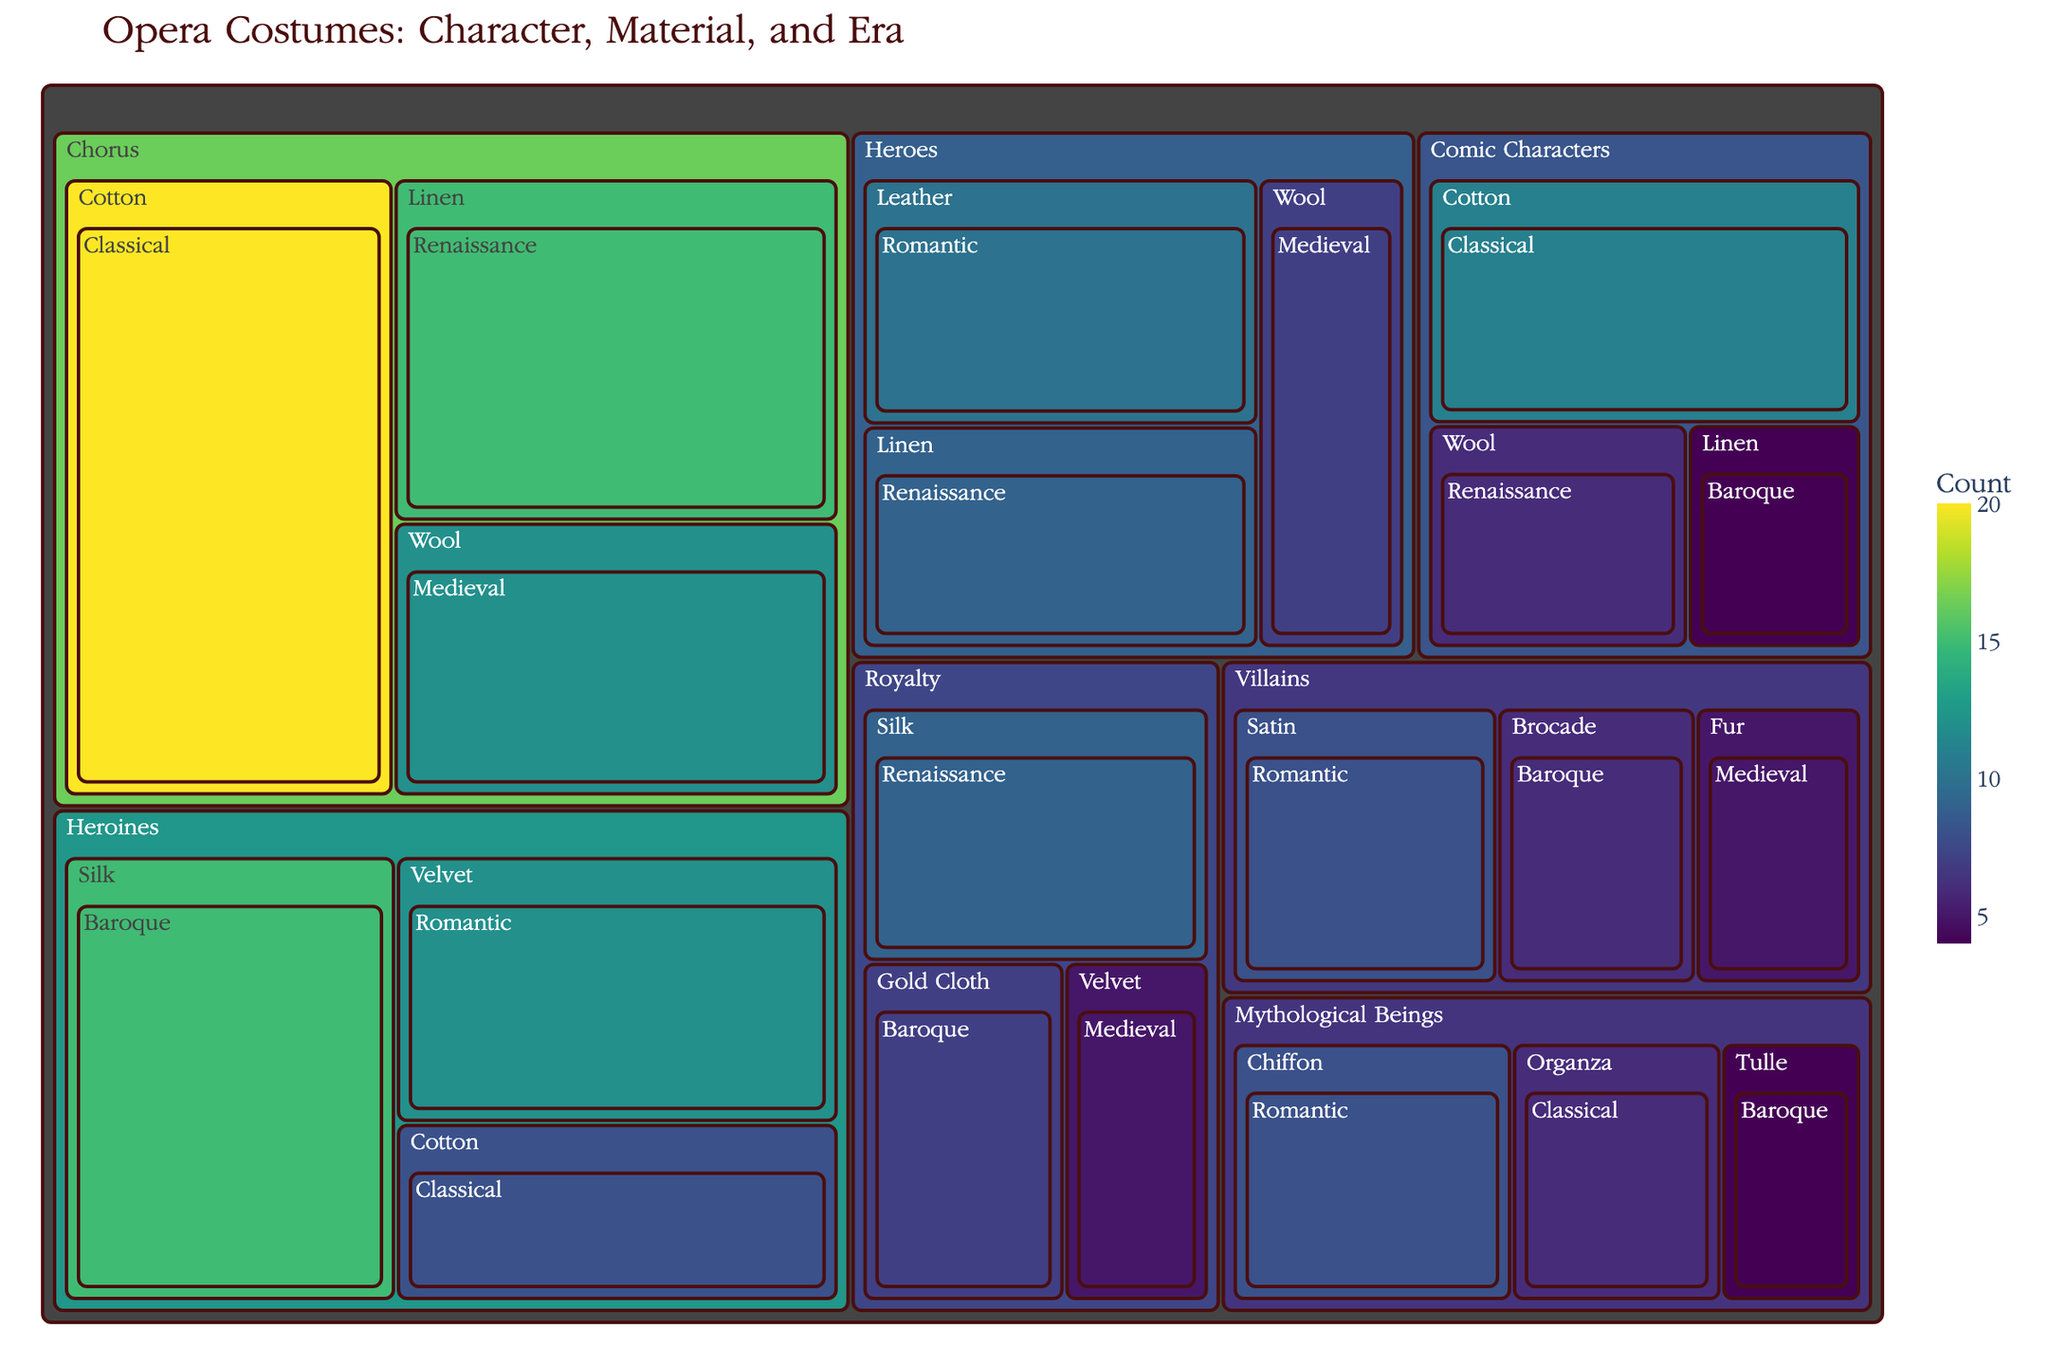What is the title of the treemap? The title of the treemap is typically displayed prominently at the top. In this case, the title is provided by us: 'Opera Costumes: Character, Material, and Era'
Answer: Opera Costumes: Character, Material, and Era What color scale is used in the treemap? The color scale is defined in the code as 'Viridis'. This scale is typically a gradient of colors transitioning from dark to light to represent the count values.
Answer: Viridis Which character type has the highest count of costumes? Look for the largest area in the treemap. The largest area corresponds to the 'Chorus', with a sum of counts from different materials and eras adding up to be the highest.
Answer: Chorus What is the total number of 'Royalty' costumes? Sum the counts of all 'Royalty' costumes across different materials and eras: 7 (Gold Cloth, Baroque) + 9 (Silk, Renaissance) + 5 (Velvet, Medieval) = 21.
Answer: 21 Which era has the most 'Heroines' costumes made of silk? Locate data points within 'Heroines' and distinguish by material and era. The count for silk in the Baroque era is 15, which is the highest for Heroines with silk.
Answer: Baroque Compare the number of 'Heroes' costumes made of wool with the number of 'Villains' costumes made of fur. Which is higher? Locate the count for 'Heroes' with wool (7) and 'Villains' with fur (5). Compare these numbers. Heroes with wool is higher.
Answer: Heroes with wool What is the total count of 'Comic Characters' costumes made of Linen and Cotton? Add counts for Linen and Cotton materials for Comic Characters: 4 (Linen, Baroque) + 11 (Cotton, Classical) = 15.
Answer: 15 How many different historical eras are represented in the dataset? Inspect the data points grouped under 'Historical Era'. There are 5 unique eras listed: Baroque, Romantic, Classical, Medieval, and Renaissance.
Answer: 5 Which character type has the least number of total costumes? Determine the total counts for each character type and identify the smallest sum. 'Villains' have the smallest total sum: 6 (Brocade, Baroque) + 5 (Fur, Medieval) + 8 (Satin, Romantic) = 19.
Answer: Villains What is the most common material used for 'Chorus' costumes in terms of quantity? Check the materials listed under 'Chorus' and compare their counts: Cotton (20), Linen (15), Wool (12). Cotton is the most common.
Answer: Cotton 